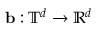Convert formula to latex. <formula><loc_0><loc_0><loc_500><loc_500>{ b } \colon { \mathbb { T } } ^ { d } \to { \mathbb { R } } ^ { d }</formula> 